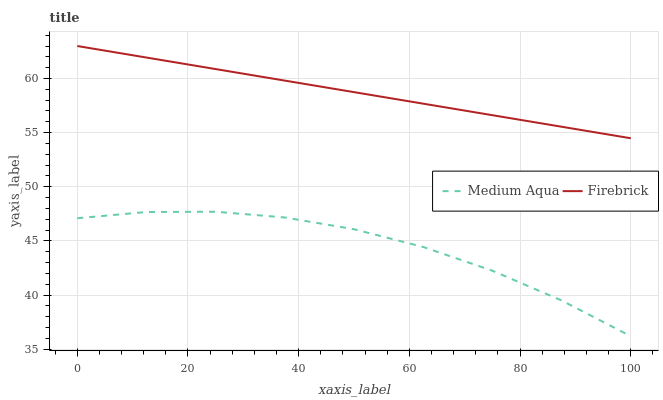Does Medium Aqua have the minimum area under the curve?
Answer yes or no. Yes. Does Firebrick have the maximum area under the curve?
Answer yes or no. Yes. Does Medium Aqua have the maximum area under the curve?
Answer yes or no. No. Is Firebrick the smoothest?
Answer yes or no. Yes. Is Medium Aqua the roughest?
Answer yes or no. Yes. Is Medium Aqua the smoothest?
Answer yes or no. No. Does Medium Aqua have the lowest value?
Answer yes or no. Yes. Does Firebrick have the highest value?
Answer yes or no. Yes. Does Medium Aqua have the highest value?
Answer yes or no. No. Is Medium Aqua less than Firebrick?
Answer yes or no. Yes. Is Firebrick greater than Medium Aqua?
Answer yes or no. Yes. Does Medium Aqua intersect Firebrick?
Answer yes or no. No. 